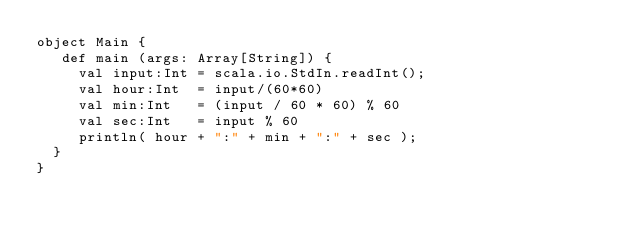<code> <loc_0><loc_0><loc_500><loc_500><_Scala_>object Main {
   def main (args: Array[String]) {
     val input:Int = scala.io.StdIn.readInt();
     val hour:Int  = input/(60*60)
     val min:Int   = (input / 60 * 60) % 60
     val sec:Int   = input % 60
     println( hour + ":" + min + ":" + sec );
  }
}</code> 